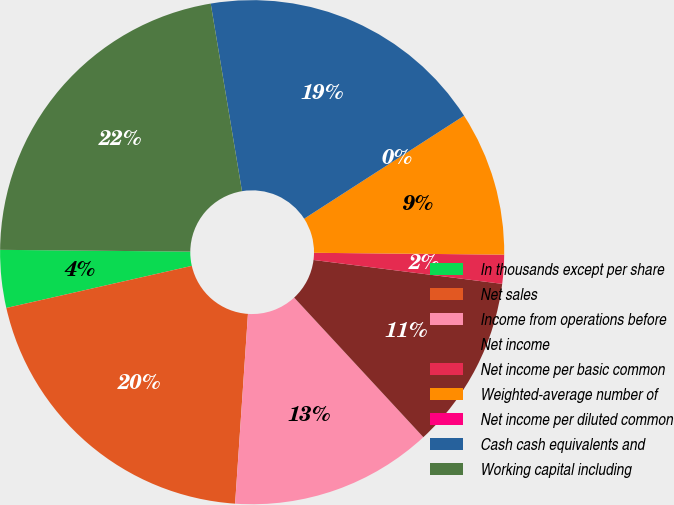Convert chart to OTSL. <chart><loc_0><loc_0><loc_500><loc_500><pie_chart><fcel>In thousands except per share<fcel>Net sales<fcel>Income from operations before<fcel>Net income<fcel>Net income per basic common<fcel>Weighted-average number of<fcel>Net income per diluted common<fcel>Cash cash equivalents and<fcel>Working capital including<nl><fcel>3.7%<fcel>20.37%<fcel>12.96%<fcel>11.11%<fcel>1.85%<fcel>9.26%<fcel>0.0%<fcel>18.52%<fcel>22.22%<nl></chart> 